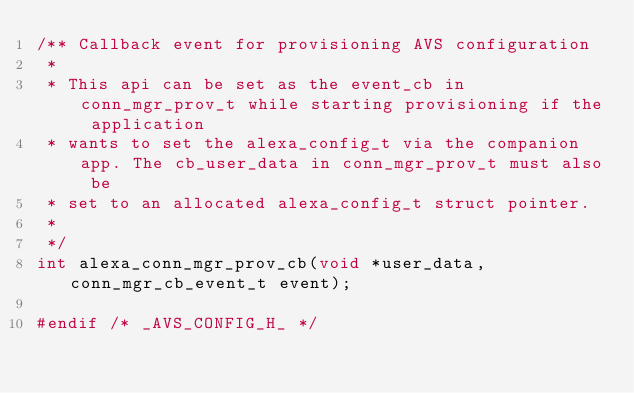<code> <loc_0><loc_0><loc_500><loc_500><_C_>/** Callback event for provisioning AVS configuration
 *
 * This api can be set as the event_cb in conn_mgr_prov_t while starting provisioning if the application
 * wants to set the alexa_config_t via the companion app. The cb_user_data in conn_mgr_prov_t must also be 
 * set to an allocated alexa_config_t struct pointer.
 *
 */
int alexa_conn_mgr_prov_cb(void *user_data, conn_mgr_cb_event_t event);

#endif /* _AVS_CONFIG_H_ */</code> 